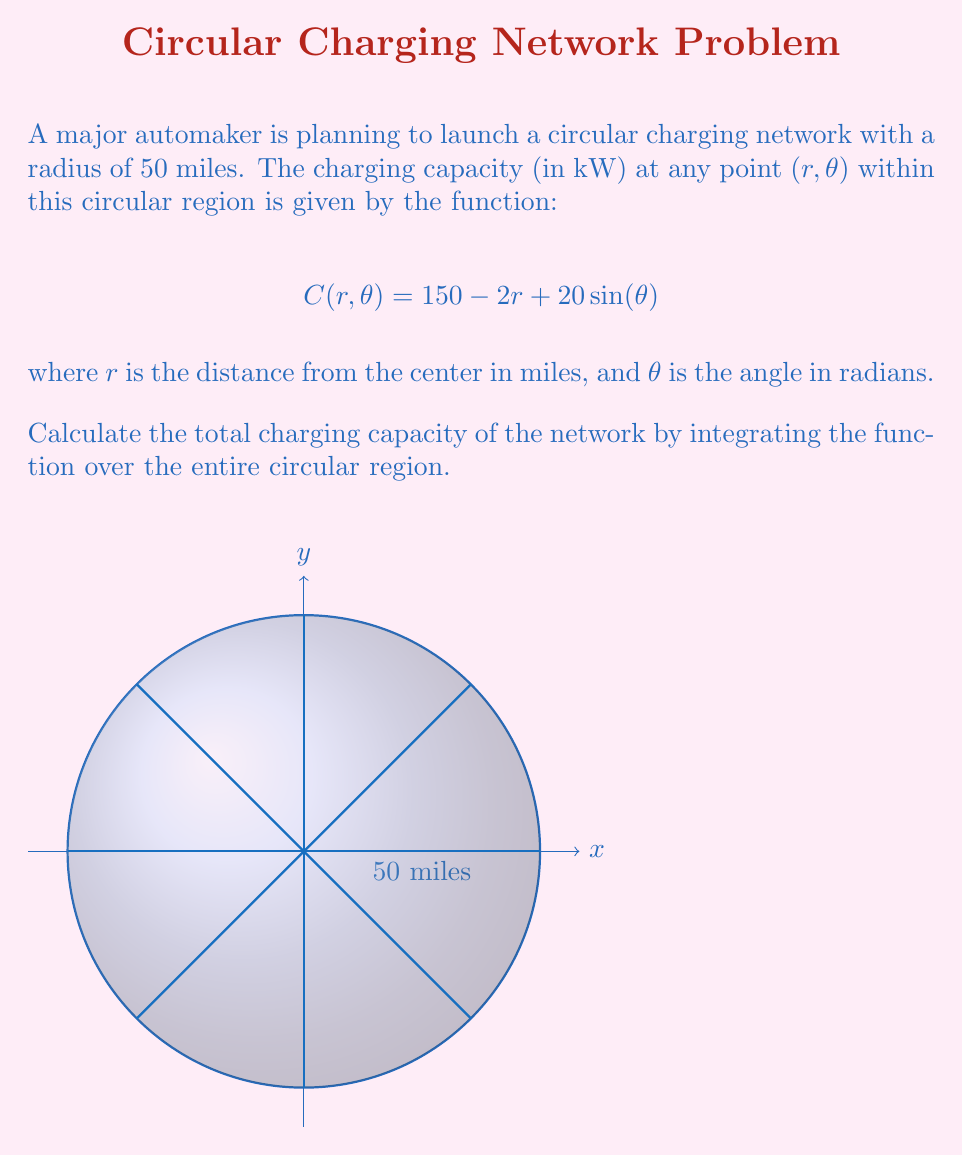Can you solve this math problem? To solve this problem, we need to use polar integration over a circular region. The steps are as follows:

1) The total charging capacity is given by the double integral of the function $C(r, \theta)$ over the circular region:

   $$\iint_R C(r, \theta) \, r \, dr \, d\theta$$

   where $R$ is the circular region with radius 50 miles.

2) In polar coordinates, the limits of integration are:
   $0 \leq r \leq 50$ and $0 \leq \theta \leq 2\pi$

3) Substituting the function and limits:

   $$\int_0^{2\pi} \int_0^{50} (150 - 2r + 20\sin(\theta)) \, r \, dr \, d\theta$$

4) Let's integrate with respect to $r$ first:

   $$\int_0^{2\pi} \left[ 150\frac{r^2}{2} - 2\frac{r^3}{3} + 20r\sin(\theta) \right]_0^{50} \, d\theta$$

5) Evaluating the inner integral:

   $$\int_0^{2\pi} \left( 187500 - 83333.33 + 1000\sin(\theta) \right) \, d\theta$$

6) Simplify:

   $$\int_0^{2\pi} (104166.67 + 1000\sin(\theta)) \, d\theta$$

7) Integrate with respect to $\theta$:

   $$\left[ 104166.67\theta - 1000\cos(\theta) \right]_0^{2\pi}$$

8) Evaluate:

   $$(104166.67 \cdot 2\pi - 1000\cos(2\pi)) - (0 - 1000\cos(0))$$
   
   $$= 654166.67 \cdot 2\pi = 4108333.33\pi$$

Therefore, the total charging capacity of the network is approximately 12,910,333.89 kW.
Answer: $4108333.33\pi$ kW $\approx 12,910,333.89$ kW 